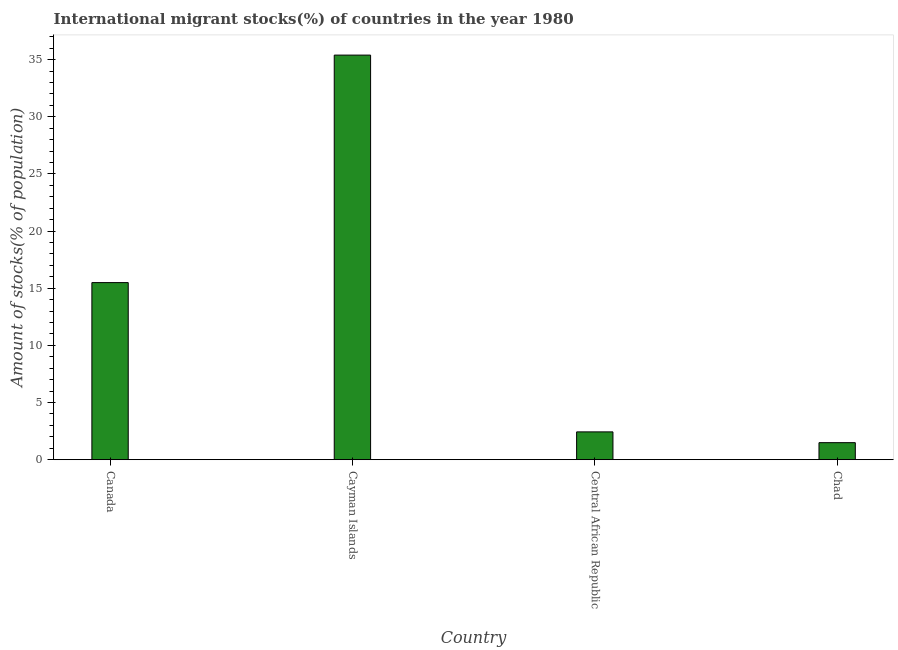Does the graph contain any zero values?
Provide a short and direct response. No. What is the title of the graph?
Keep it short and to the point. International migrant stocks(%) of countries in the year 1980. What is the label or title of the Y-axis?
Give a very brief answer. Amount of stocks(% of population). What is the number of international migrant stocks in Chad?
Your answer should be compact. 1.49. Across all countries, what is the maximum number of international migrant stocks?
Your answer should be compact. 35.4. Across all countries, what is the minimum number of international migrant stocks?
Make the answer very short. 1.49. In which country was the number of international migrant stocks maximum?
Provide a short and direct response. Cayman Islands. In which country was the number of international migrant stocks minimum?
Your answer should be very brief. Chad. What is the sum of the number of international migrant stocks?
Provide a short and direct response. 54.82. What is the difference between the number of international migrant stocks in Cayman Islands and Central African Republic?
Your answer should be very brief. 32.97. What is the average number of international migrant stocks per country?
Ensure brevity in your answer.  13.71. What is the median number of international migrant stocks?
Keep it short and to the point. 8.96. What is the ratio of the number of international migrant stocks in Cayman Islands to that in Chad?
Keep it short and to the point. 23.75. Is the difference between the number of international migrant stocks in Canada and Chad greater than the difference between any two countries?
Keep it short and to the point. No. What is the difference between the highest and the second highest number of international migrant stocks?
Give a very brief answer. 19.91. Is the sum of the number of international migrant stocks in Central African Republic and Chad greater than the maximum number of international migrant stocks across all countries?
Give a very brief answer. No. What is the difference between the highest and the lowest number of international migrant stocks?
Ensure brevity in your answer.  33.91. In how many countries, is the number of international migrant stocks greater than the average number of international migrant stocks taken over all countries?
Ensure brevity in your answer.  2. How many bars are there?
Provide a succinct answer. 4. How many countries are there in the graph?
Offer a terse response. 4. What is the Amount of stocks(% of population) of Canada?
Your answer should be very brief. 15.49. What is the Amount of stocks(% of population) of Cayman Islands?
Your answer should be very brief. 35.4. What is the Amount of stocks(% of population) of Central African Republic?
Provide a short and direct response. 2.43. What is the Amount of stocks(% of population) in Chad?
Give a very brief answer. 1.49. What is the difference between the Amount of stocks(% of population) in Canada and Cayman Islands?
Ensure brevity in your answer.  -19.91. What is the difference between the Amount of stocks(% of population) in Canada and Central African Republic?
Provide a succinct answer. 13.06. What is the difference between the Amount of stocks(% of population) in Canada and Chad?
Provide a succinct answer. 14. What is the difference between the Amount of stocks(% of population) in Cayman Islands and Central African Republic?
Give a very brief answer. 32.97. What is the difference between the Amount of stocks(% of population) in Cayman Islands and Chad?
Offer a terse response. 33.91. What is the difference between the Amount of stocks(% of population) in Central African Republic and Chad?
Ensure brevity in your answer.  0.94. What is the ratio of the Amount of stocks(% of population) in Canada to that in Cayman Islands?
Make the answer very short. 0.44. What is the ratio of the Amount of stocks(% of population) in Canada to that in Central African Republic?
Provide a short and direct response. 6.37. What is the ratio of the Amount of stocks(% of population) in Canada to that in Chad?
Offer a very short reply. 10.39. What is the ratio of the Amount of stocks(% of population) in Cayman Islands to that in Central African Republic?
Provide a succinct answer. 14.54. What is the ratio of the Amount of stocks(% of population) in Cayman Islands to that in Chad?
Your response must be concise. 23.75. What is the ratio of the Amount of stocks(% of population) in Central African Republic to that in Chad?
Offer a very short reply. 1.63. 